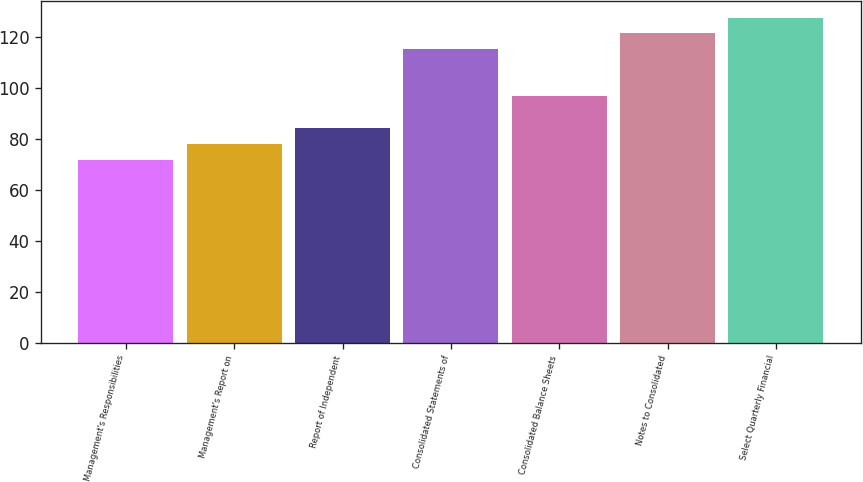<chart> <loc_0><loc_0><loc_500><loc_500><bar_chart><fcel>Management's Responsibilities<fcel>Management's Report on<fcel>Report of Independent<fcel>Consolidated Statements of<fcel>Consolidated Balance Sheets<fcel>Notes to Consolidated<fcel>Select Quarterly Financial<nl><fcel>72<fcel>78.2<fcel>84.4<fcel>115.4<fcel>96.8<fcel>121.6<fcel>127.8<nl></chart> 